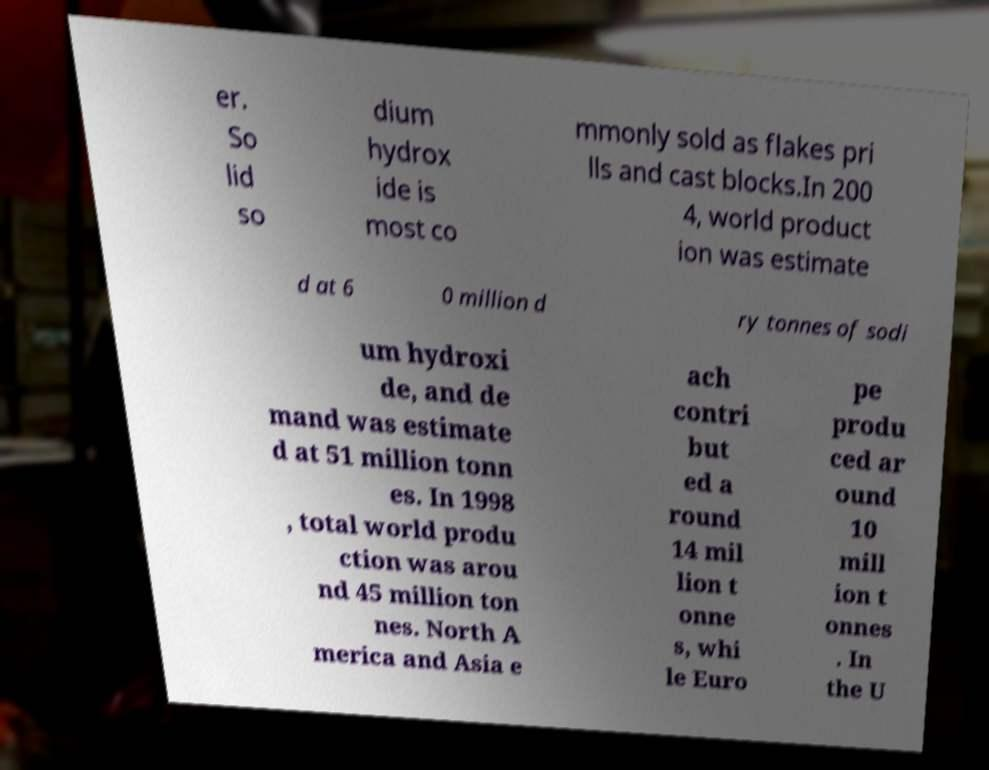Please identify and transcribe the text found in this image. er. So lid so dium hydrox ide is most co mmonly sold as flakes pri lls and cast blocks.In 200 4, world product ion was estimate d at 6 0 million d ry tonnes of sodi um hydroxi de, and de mand was estimate d at 51 million tonn es. In 1998 , total world produ ction was arou nd 45 million ton nes. North A merica and Asia e ach contri but ed a round 14 mil lion t onne s, whi le Euro pe produ ced ar ound 10 mill ion t onnes . In the U 